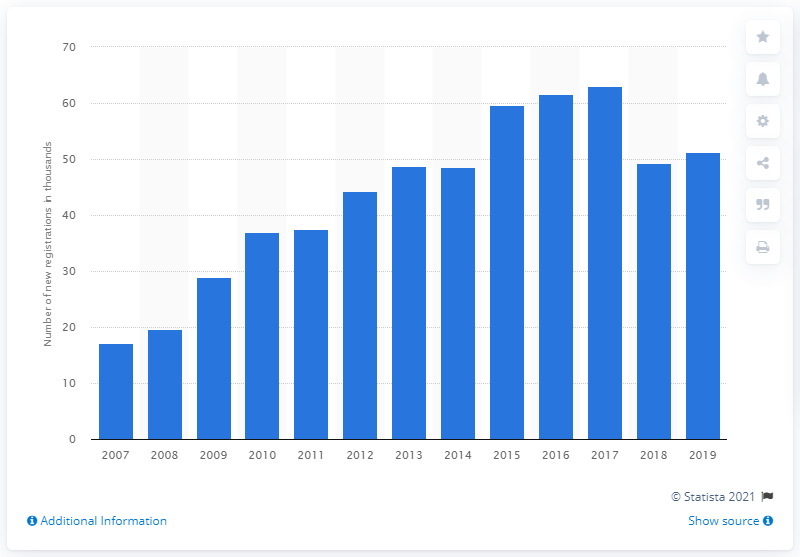Mention a couple of crucial points in this snapshot. In 2017, a peak in sales of the Nissan Qashqai was observed. 